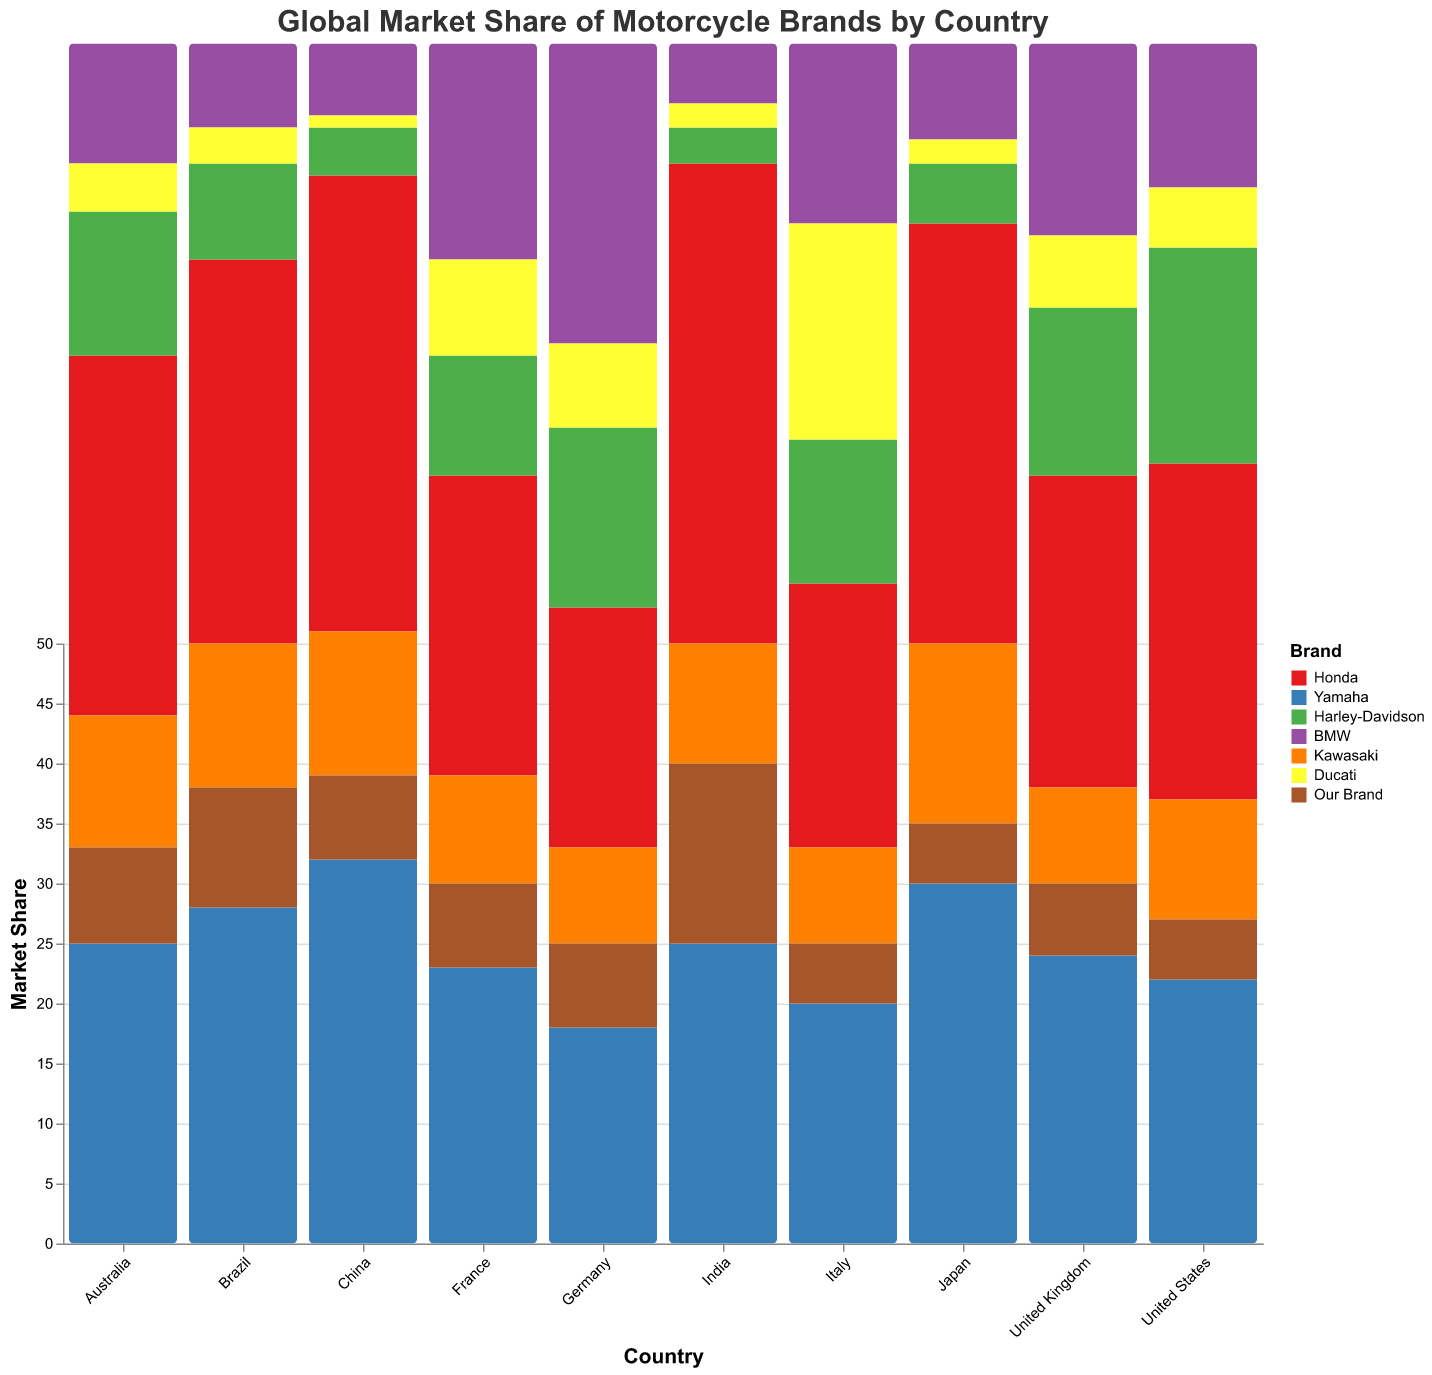Which country has the highest market share for Honda? By examining the bars colored for Honda in each country, the highest bar corresponds to India.
Answer: India What is the total market share of our brand across all countries? Summing the market share of our brand for each country: 5 (United States) + 7 (Germany) + 5 (Japan) + 15 (India) + 10 (Brazil) + 5 (Italy) + 7 (France) + 6 (United Kingdom) + 8 (Australia) + 7 (China) = 75
Answer: 75 How does the market share of Yamaha in China compare to its share in Japan? Yamaha's share in China is 32, while in Japan it is 30. Thus, Yamaha has a higher market share in China compared to Japan.
Answer: China has a higher share Which brand has the highest market share in Germany? By comparing the heights of the bars for each brand in Germany, the BMW bar is the tallest at 25.
Answer: BMW In which country does our brand have the lowest market share? Our brand's lowest market shares are 5, seen in both the United States, Japan, and Italy.
Answer: United States, Japan, and Italy What's the difference in Ducati's market share between Italy and China? Ducati's market share in Italy is 18, while in China it is 1. The difference is 18 - 1 = 17.
Answer: 17 Which brand is consistently within the top two market shares in most countries? By observing the bars for each brand in each country, Honda appears within the top two in almost every country.
Answer: Honda What is the average market share of Kawasaki across all countries? Adding the market share of Kawasaki for each country: 10 (United States) + 8 (Germany) + 15 (Japan) + 10 (India) + 12 (Brazil) + 8 (Italy) + 9 (France) + 8 (United Kingdom) + 11 (Australia) + 12 (China) = 103. The average is 103/10 = 10.3
Answer: 10.3 Which country has the most balanced market distribution, where no single brand dominates significantly? Observing the countries, Germany shows a relatively balanced distribution where the highest share is 25 (BMW) and the other brands have similar shares.
Answer: Germany 